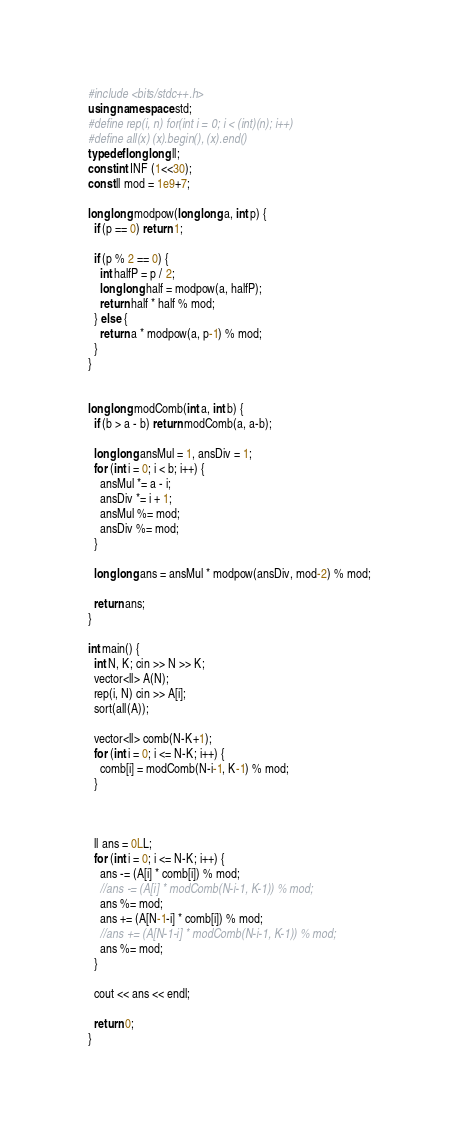Convert code to text. <code><loc_0><loc_0><loc_500><loc_500><_C++_>#include <bits/stdc++.h>
using namespace std;
#define rep(i, n) for(int i = 0; i < (int)(n); i++)
#define all(x) (x).begin(), (x).end()
typedef long long ll;
const int INF (1<<30);
const ll mod = 1e9+7;

long long modpow(long long a, int p) {
  if (p == 0) return 1;

  if (p % 2 == 0) {
    int halfP = p / 2;
    long long half = modpow(a, halfP);
    return half * half % mod;
  } else {
    return a * modpow(a, p-1) % mod;
  }
}


long long modComb(int a, int b) {
  if (b > a - b) return modComb(a, a-b);

  long long ansMul = 1, ansDiv = 1;
  for (int i = 0; i < b; i++) {
    ansMul *= a - i;
    ansDiv *= i + 1;
    ansMul %= mod;
    ansDiv %= mod;
  }

  long long ans = ansMul * modpow(ansDiv, mod-2) % mod;

  return ans;
}

int main() {
  int N, K; cin >> N >> K;
  vector<ll> A(N);
  rep(i, N) cin >> A[i];
  sort(all(A));
  
  vector<ll> comb(N-K+1);
  for (int i = 0; i <= N-K; i++) {
    comb[i] = modComb(N-i-1, K-1) % mod;
  }

  

  ll ans = 0LL;
  for (int i = 0; i <= N-K; i++) {
    ans -= (A[i] * comb[i]) % mod;
    //ans -= (A[i] * modComb(N-i-1, K-1)) % mod;
    ans %= mod;
    ans += (A[N-1-i] * comb[i]) % mod;
    //ans += (A[N-1-i] * modComb(N-i-1, K-1)) % mod;
    ans %= mod;
  }

  cout << ans << endl;

  return 0;
}
</code> 